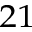<formula> <loc_0><loc_0><loc_500><loc_500>^ { 2 1 }</formula> 